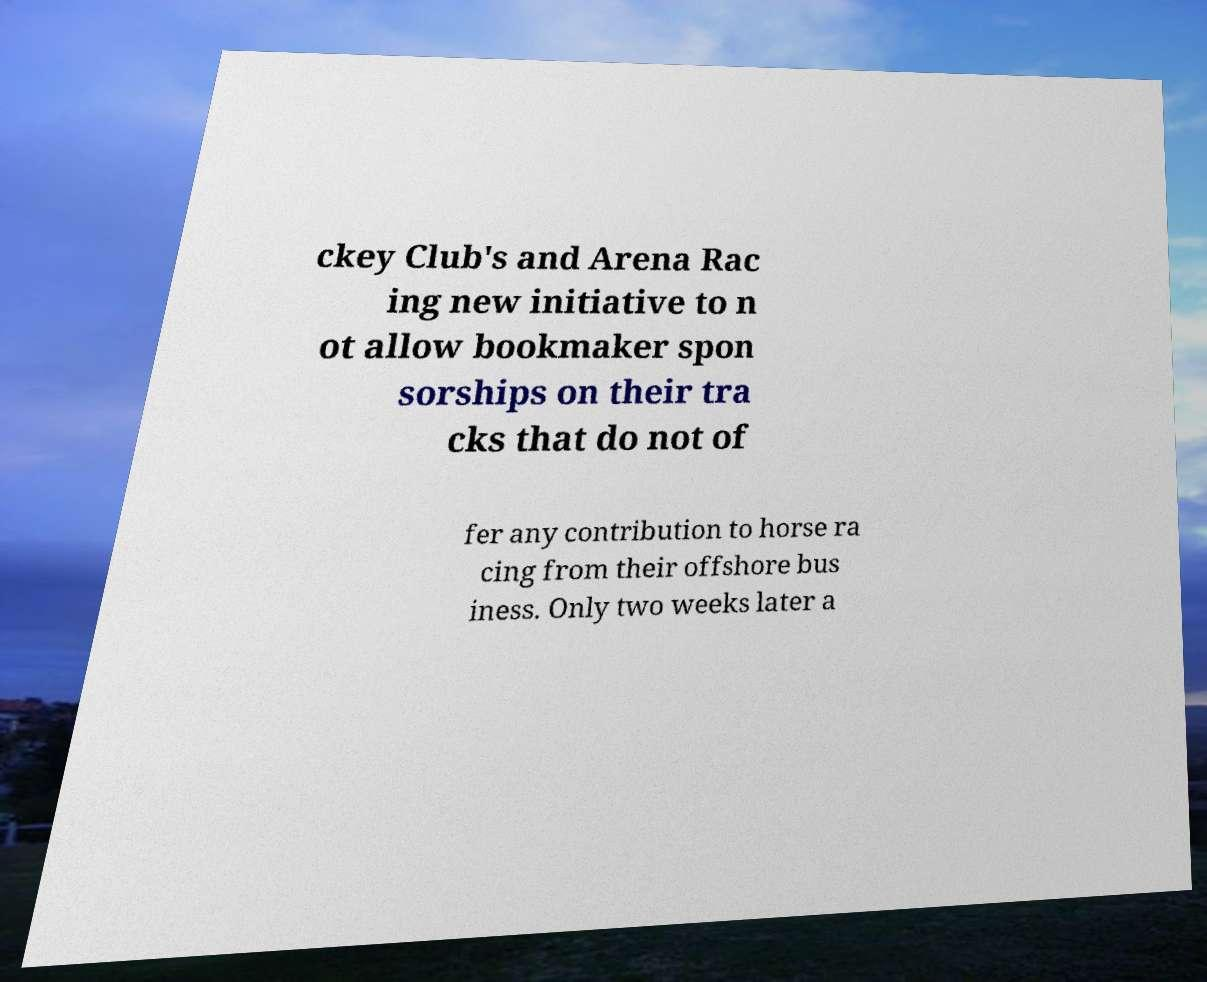What messages or text are displayed in this image? I need them in a readable, typed format. ckey Club's and Arena Rac ing new initiative to n ot allow bookmaker spon sorships on their tra cks that do not of fer any contribution to horse ra cing from their offshore bus iness. Only two weeks later a 